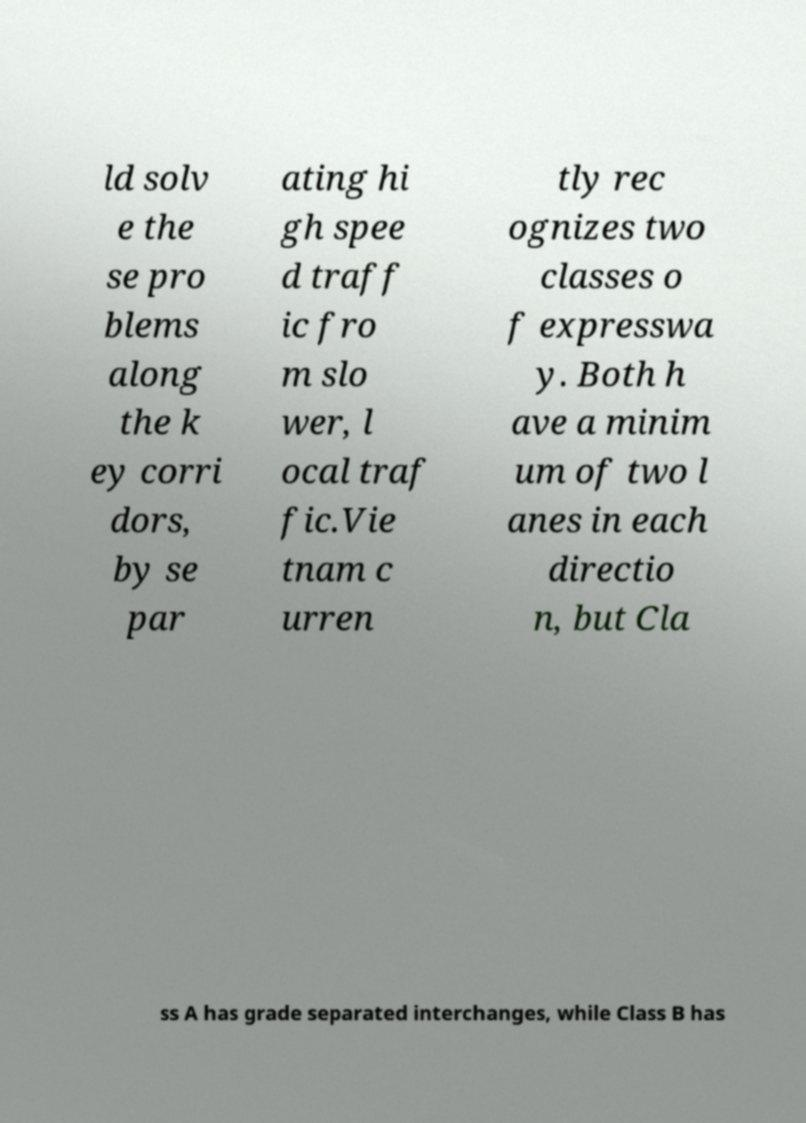Could you extract and type out the text from this image? ld solv e the se pro blems along the k ey corri dors, by se par ating hi gh spee d traff ic fro m slo wer, l ocal traf fic.Vie tnam c urren tly rec ognizes two classes o f expresswa y. Both h ave a minim um of two l anes in each directio n, but Cla ss A has grade separated interchanges, while Class B has 